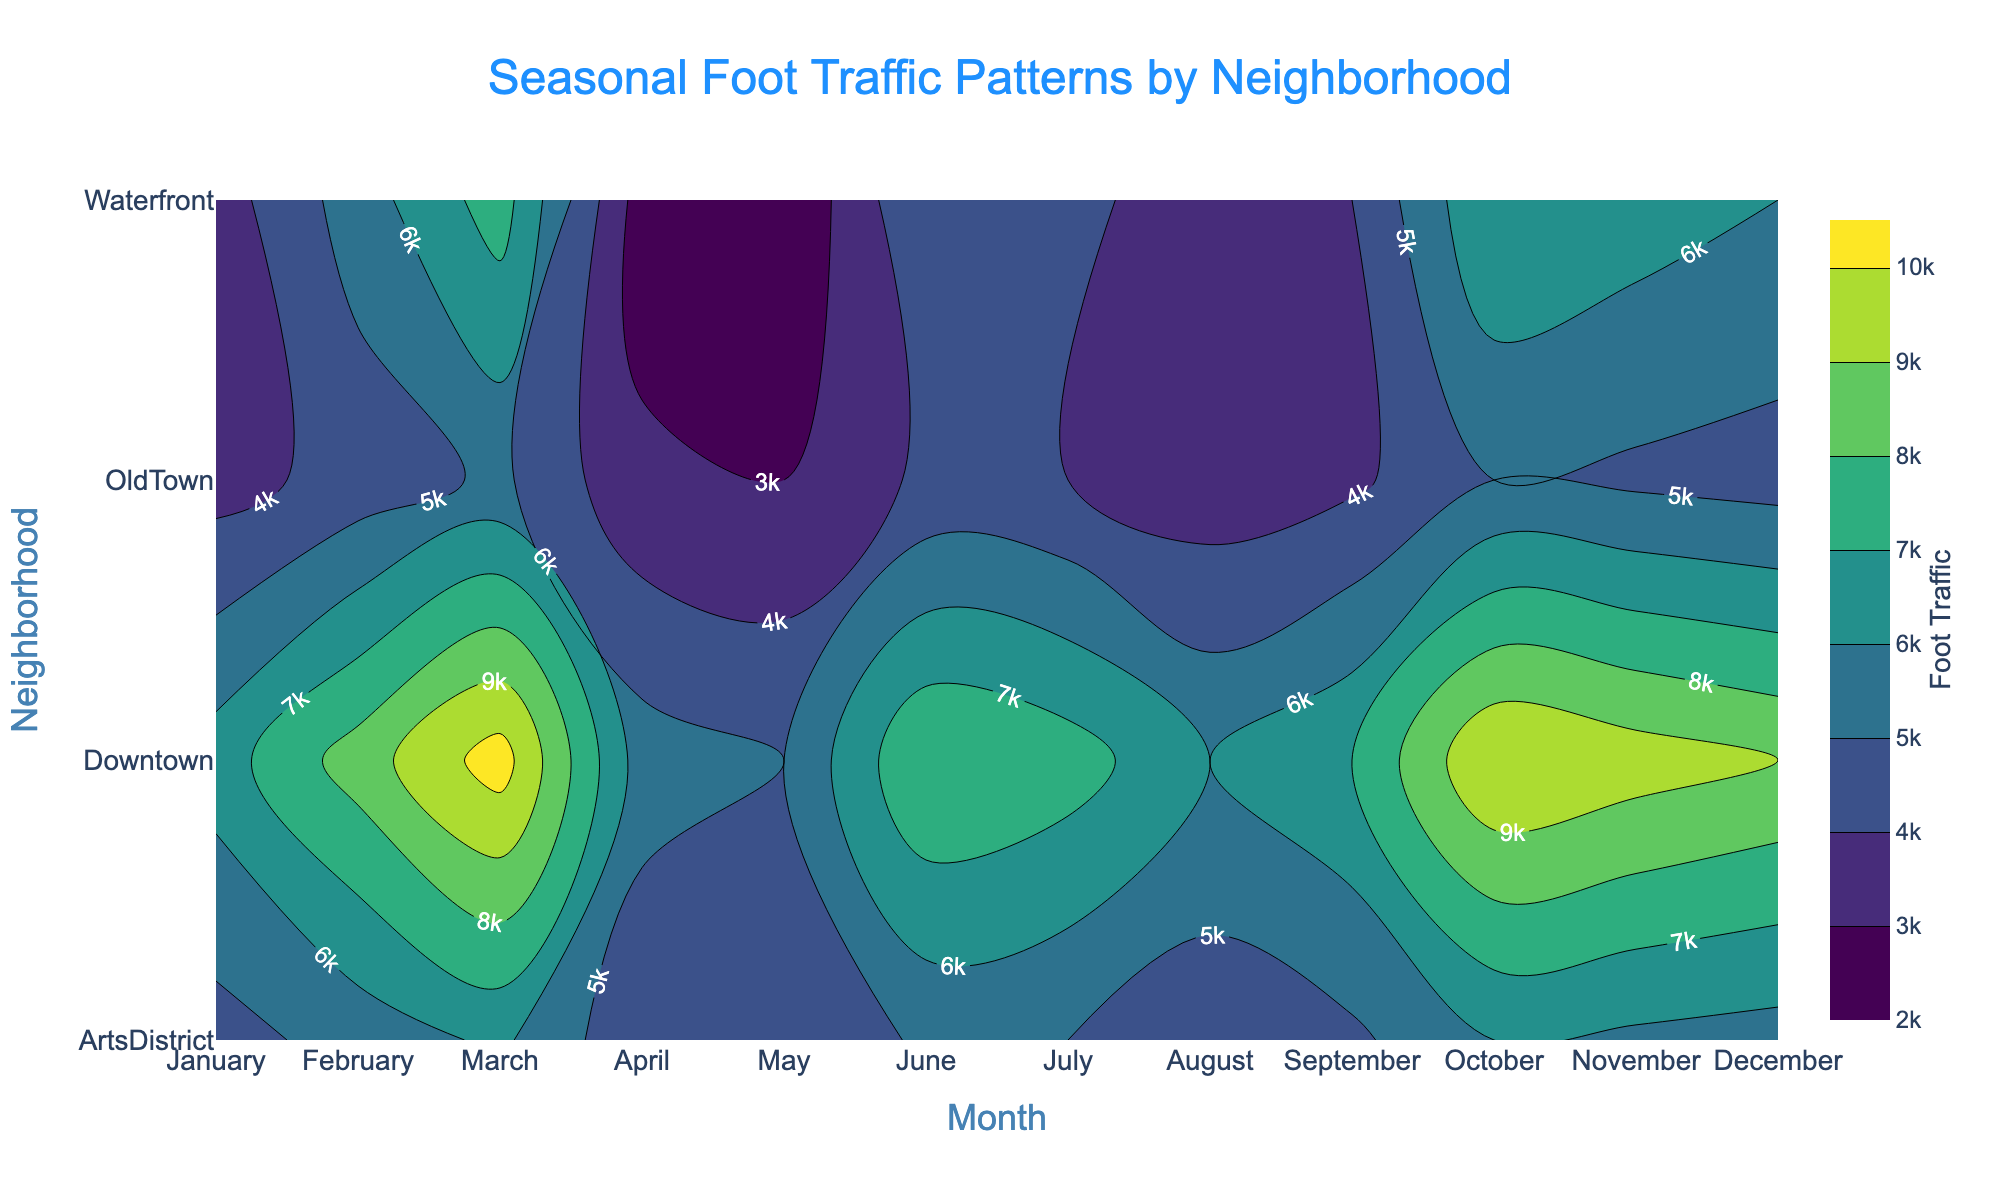What is the highest foot traffic value in any neighborhood for December? We observe the contour plot and look at December, focusing on the color intensity and contour labels across different neighborhoods. Downtown shows the highest value, reaching 10500.
Answer: 10500 Which neighborhood has the lowest foot traffic in January? By scanning the January column from top to bottom, we see that Waterfront is colored with the least intense color and labeled 2000, the lowest value.
Answer: Waterfront How would you rank the neighborhoods by their foot traffic in July? Reviewing the July column and the contour labels: Downtown (8000), Waterfront (5000), OldTown (4200), ArtsDistrict (5200). So the rank from highest to lowest is Downtown, ArtsDistrict, Waterfront, OldTown.
Answer: Downtown, ArtsDistrict, Waterfront, OldTown What is the average foot traffic for Waterfront over the year? Adding up the foot traffic values for each month for Waterfront (2000 + 2500 + 3000 + 3500 + 4000 + 4500 + 5000 + 5500 + 6000 + 6500 + 7000 + 7500) and dividing by 12, the average is (57000 / 12) = 4750
Answer: 4750 Compare foot traffic between Downtown and ArtsDistrict for April. Which neighborhood has higher foot traffic, and by how much? Checking the contour labels for April, Downtown has 6500 and ArtsDistrict has 4600. The difference is 6500 - 4600 = 1900, so Downtown is higher by 1900.
Answer: Downtown by 1900 Which months have the steepest increase in foot traffic in Downtown? By noting the consecutive months with large foot traffic differences in the Downtown row, the sharpest increases are from August (8500) to September (9000), an increase of 500, and November (10000) to December (10500), another increase of 500. Both these intervals show steep increases.
Answer: August to September, November to December What is the total foot traffic for OldTown in the first quarter of the year (January to March)? Summing up the values for OldTown in January (3000), February (3200), and March (3400): 3000 + 3200 + 3400 = 9600.
Answer: 9600 